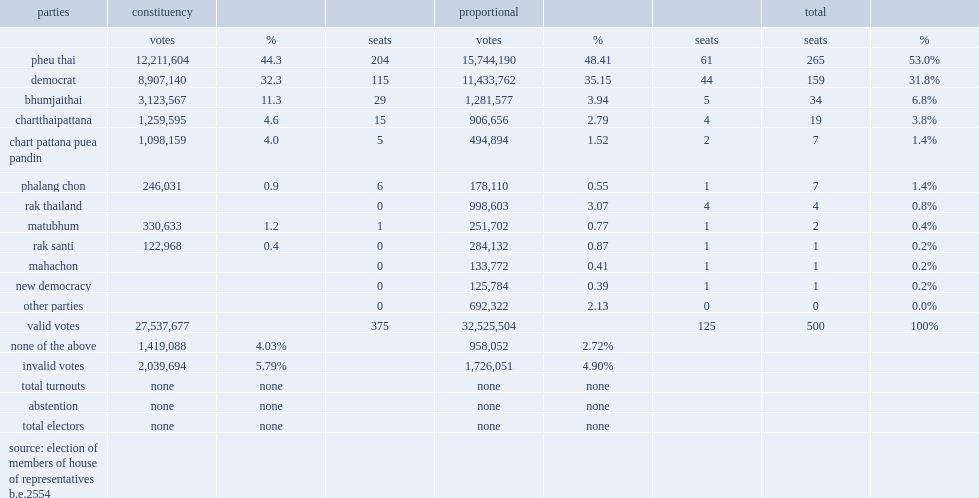How many constituencies did the 2011 thai general election cover? 375.0. How many proportional party lists did the 2011 thai general election cover? 125.0. 